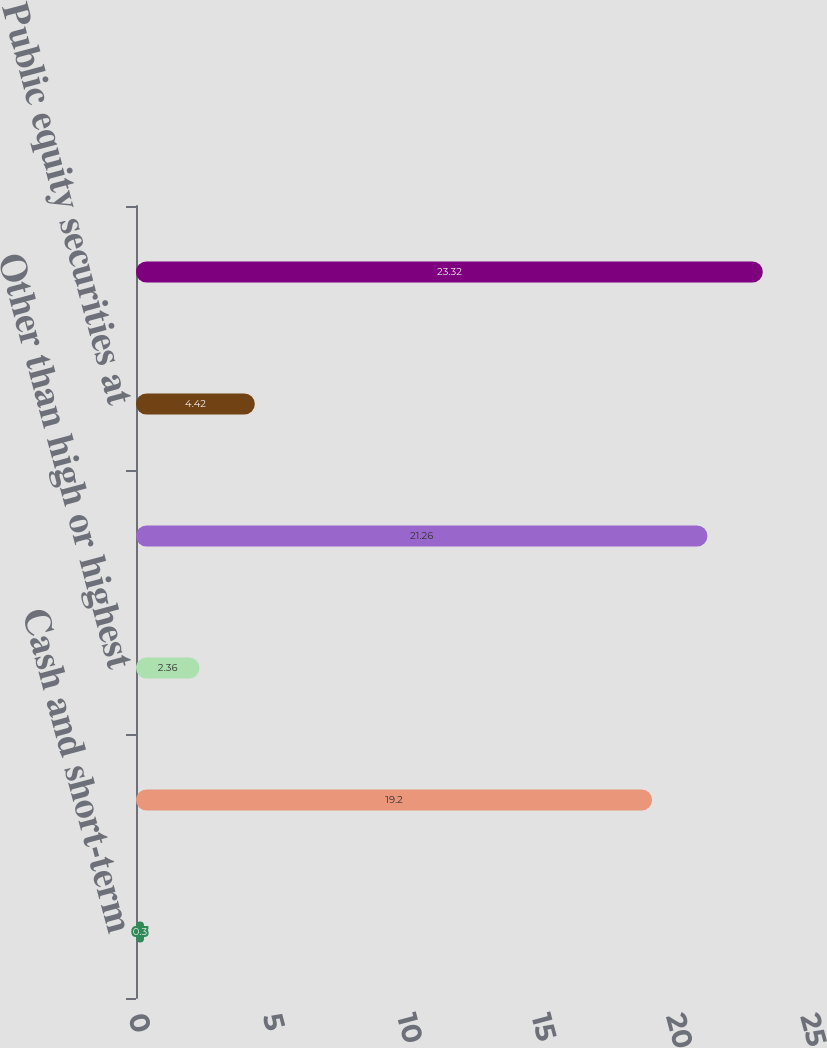<chart> <loc_0><loc_0><loc_500><loc_500><bar_chart><fcel>Cash and short-term<fcel>High or highest quality<fcel>Other than high or highest<fcel>Subtotal<fcel>Public equity securities at<fcel>Total<nl><fcel>0.3<fcel>19.2<fcel>2.36<fcel>21.26<fcel>4.42<fcel>23.32<nl></chart> 